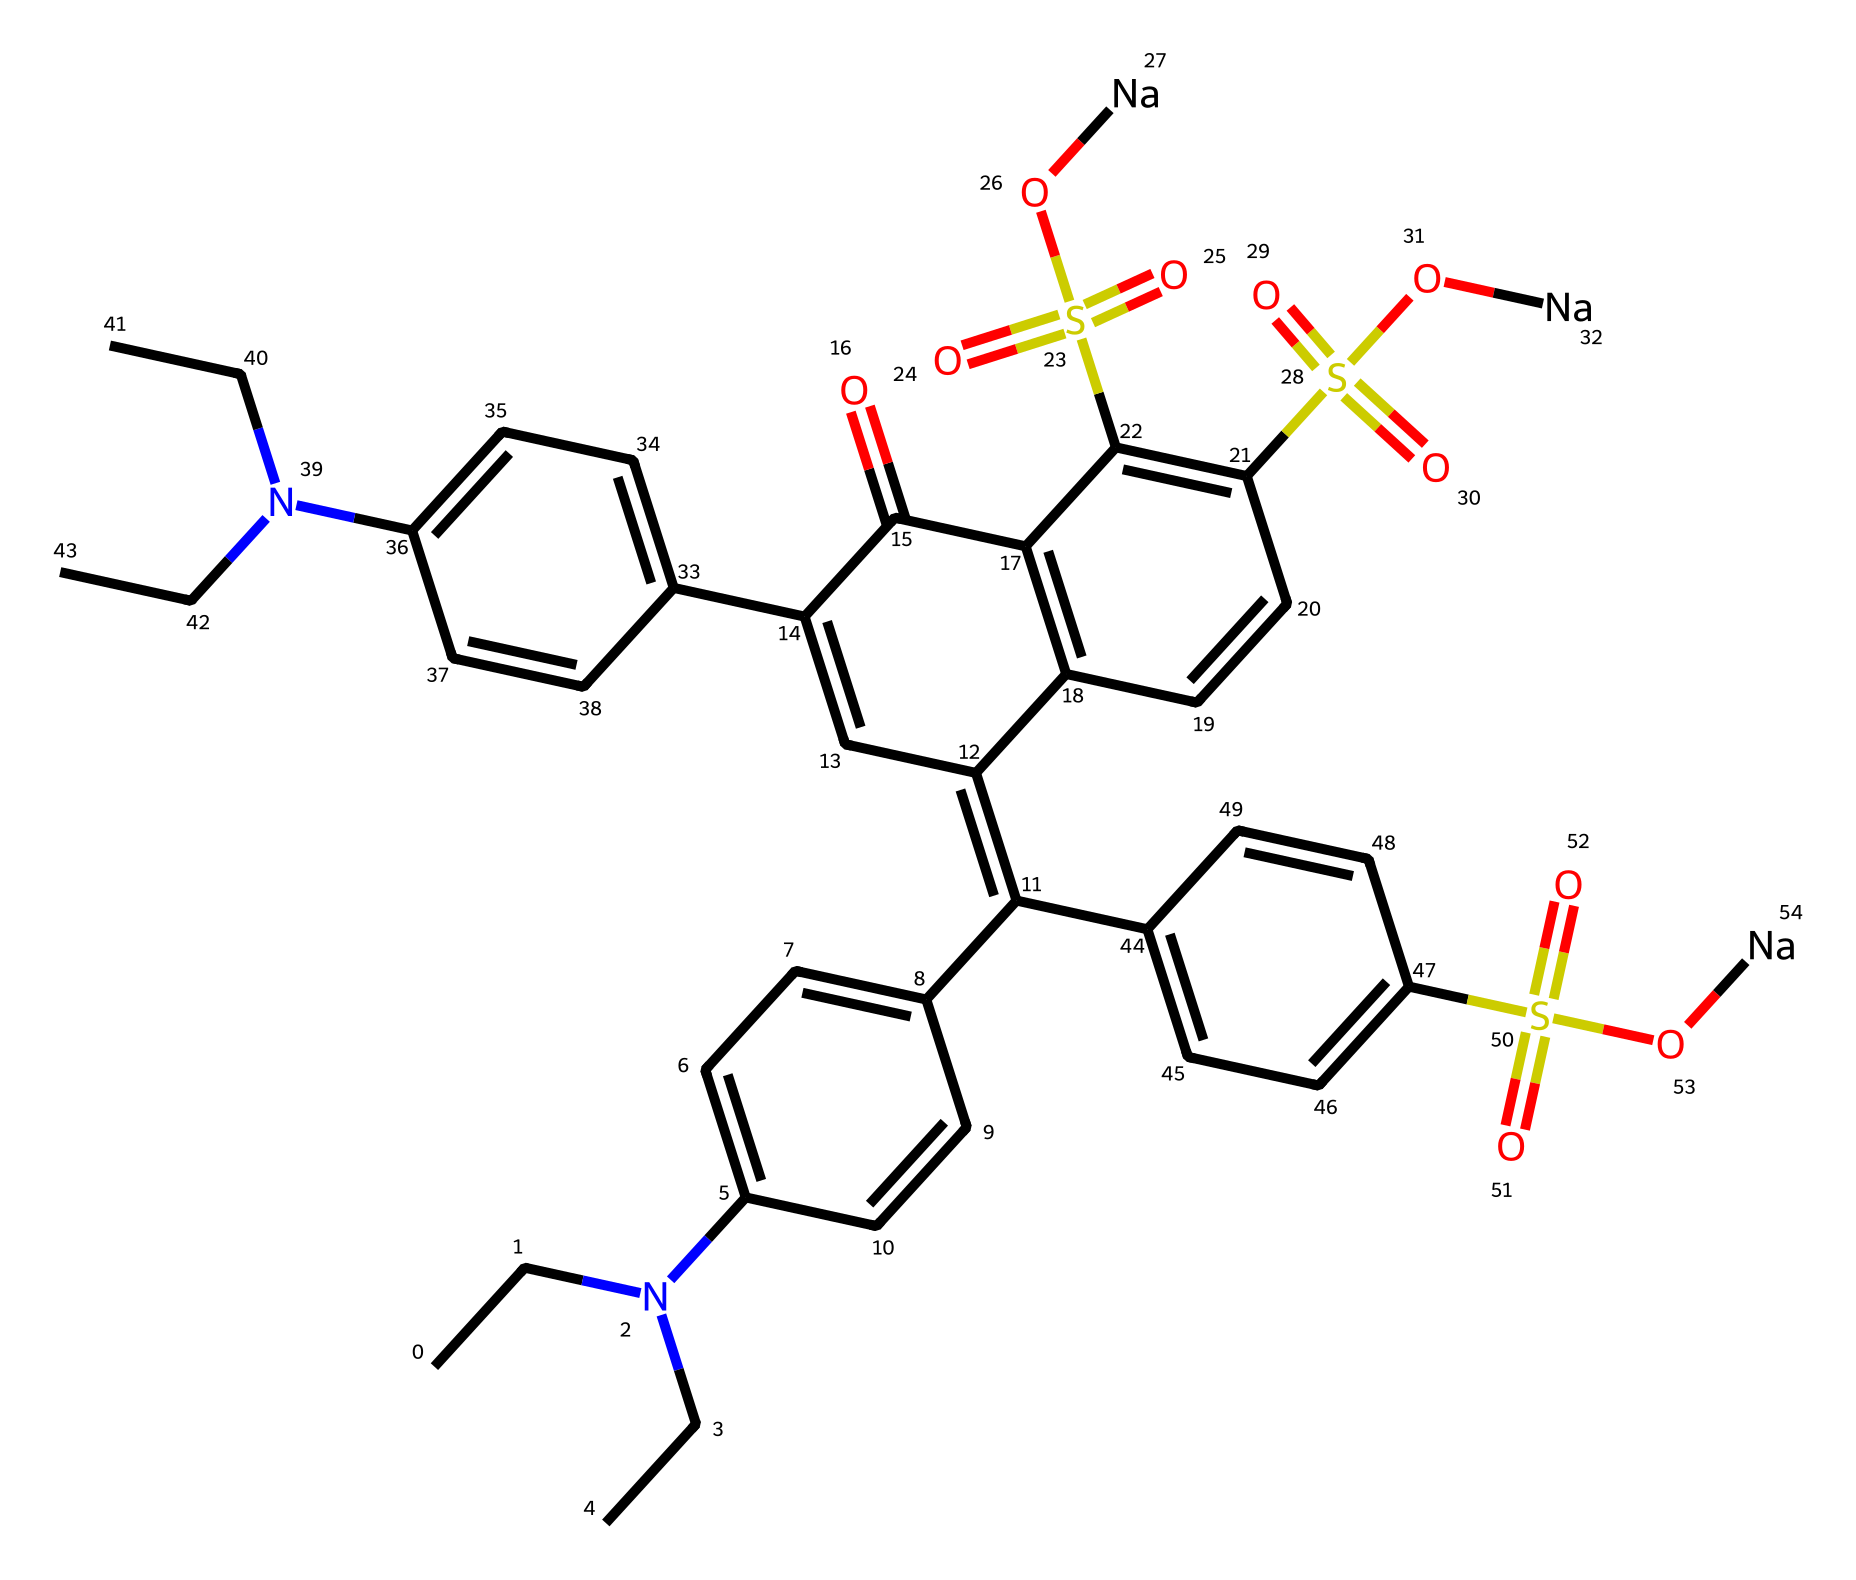How many nitrogen atoms are present in this chemical? By examining the SMILES representation, we can identify nitrogen atoms based on the presence of the letter 'N'. Counting each occurrence, we can determine there are four nitrogen atoms in the molecule.
Answer: 4 What is the primary functional group associated with this red food coloring? The chemical contains multiple sulfonate groups, which are represented by the 'S(=O)(=O)O' structure in the SMILES. This indicates the presence of sulfonic acid functional groups, a common characteristic of dyes.
Answer: sulfonic acid How many rings are present in the chemical structure? Observing the complex structure, we can spot five distinct cyclic structures. By identifying parts of the structure that form closed loops (rings), we conclude that there are five rings in total.
Answer: 5 Does this compound contain any sodium ions? The notation '[Na]' seen in the SMILES indicates the presence of sodium ions, specifically associated with the sulfonate groups. Thus, two sodium ions can be directly counted in the structure.
Answer: 2 What type of dye is this compound classified as? Given its molecular structure and functional groups, particularly the presence of sulfonic acids, this compound can be classified as an azo dye or a related type used for coloring foods.
Answer: azo dye 